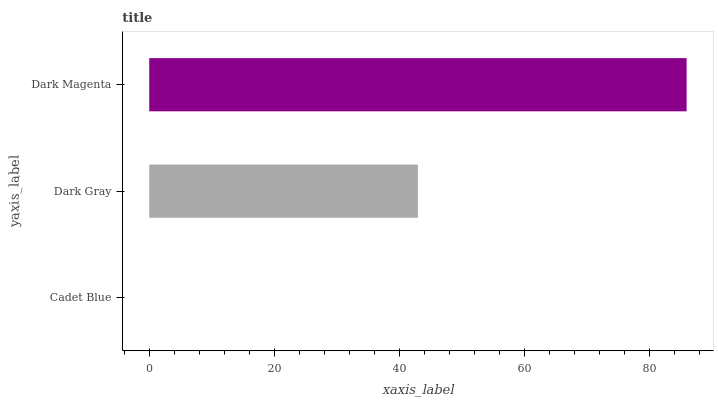Is Cadet Blue the minimum?
Answer yes or no. Yes. Is Dark Magenta the maximum?
Answer yes or no. Yes. Is Dark Gray the minimum?
Answer yes or no. No. Is Dark Gray the maximum?
Answer yes or no. No. Is Dark Gray greater than Cadet Blue?
Answer yes or no. Yes. Is Cadet Blue less than Dark Gray?
Answer yes or no. Yes. Is Cadet Blue greater than Dark Gray?
Answer yes or no. No. Is Dark Gray less than Cadet Blue?
Answer yes or no. No. Is Dark Gray the high median?
Answer yes or no. Yes. Is Dark Gray the low median?
Answer yes or no. Yes. Is Cadet Blue the high median?
Answer yes or no. No. Is Cadet Blue the low median?
Answer yes or no. No. 